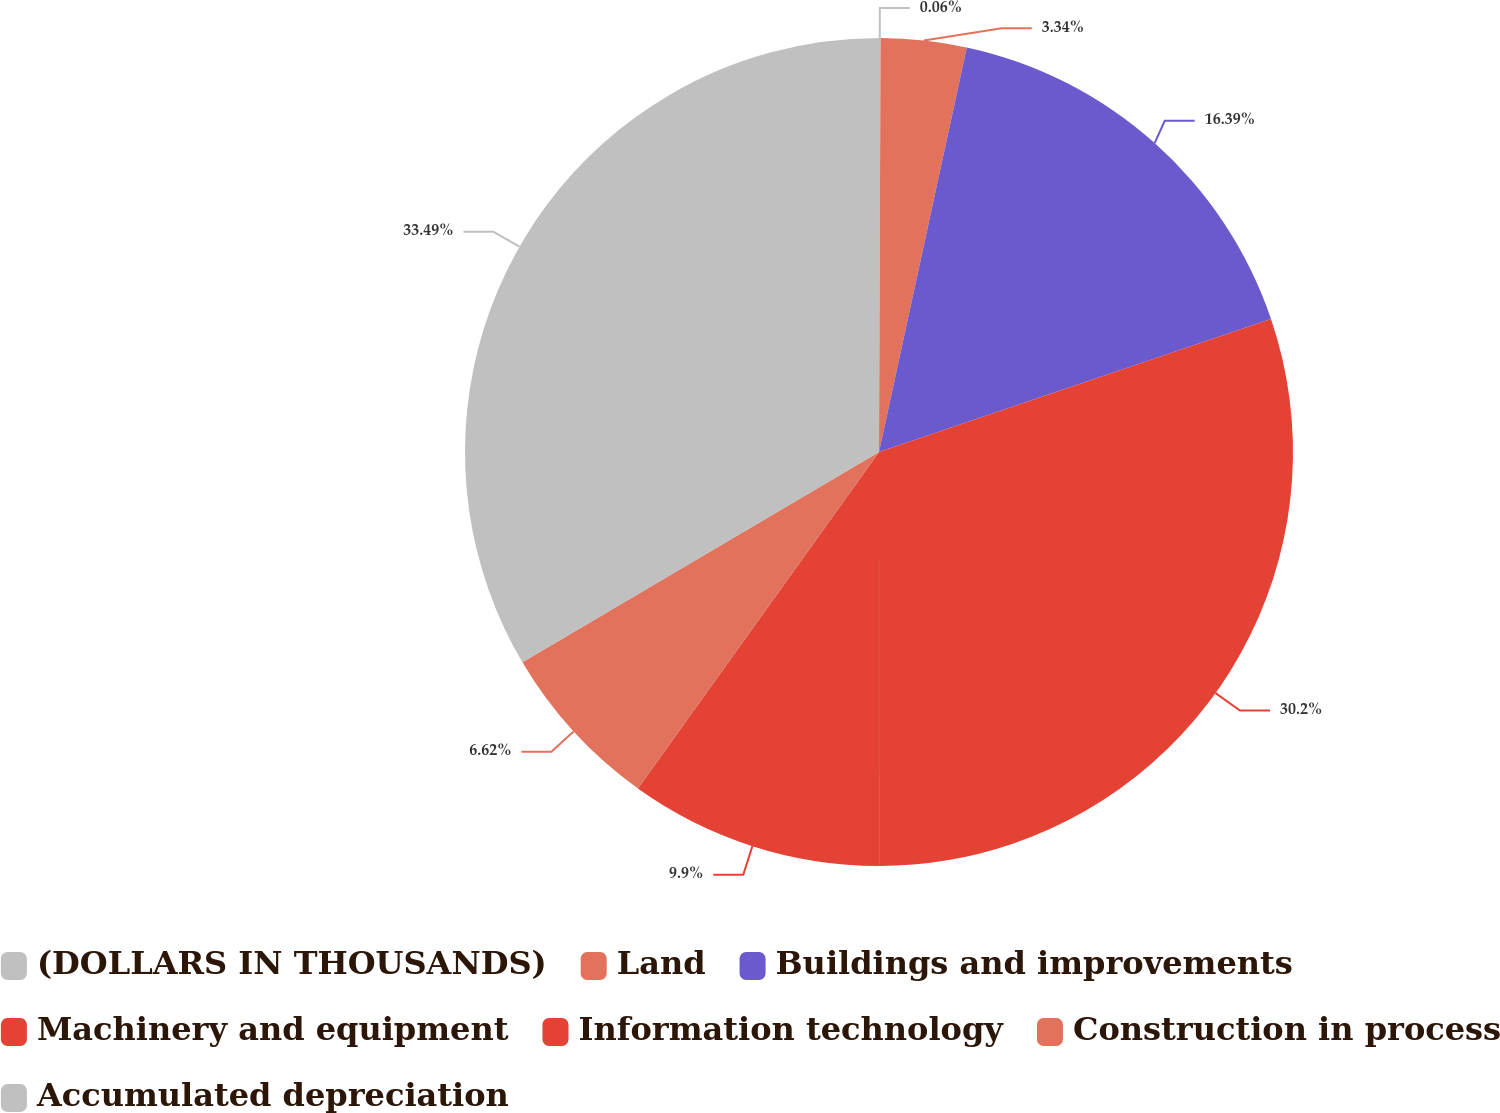Convert chart. <chart><loc_0><loc_0><loc_500><loc_500><pie_chart><fcel>(DOLLARS IN THOUSANDS)<fcel>Land<fcel>Buildings and improvements<fcel>Machinery and equipment<fcel>Information technology<fcel>Construction in process<fcel>Accumulated depreciation<nl><fcel>0.06%<fcel>3.34%<fcel>16.39%<fcel>30.2%<fcel>9.9%<fcel>6.62%<fcel>33.48%<nl></chart> 